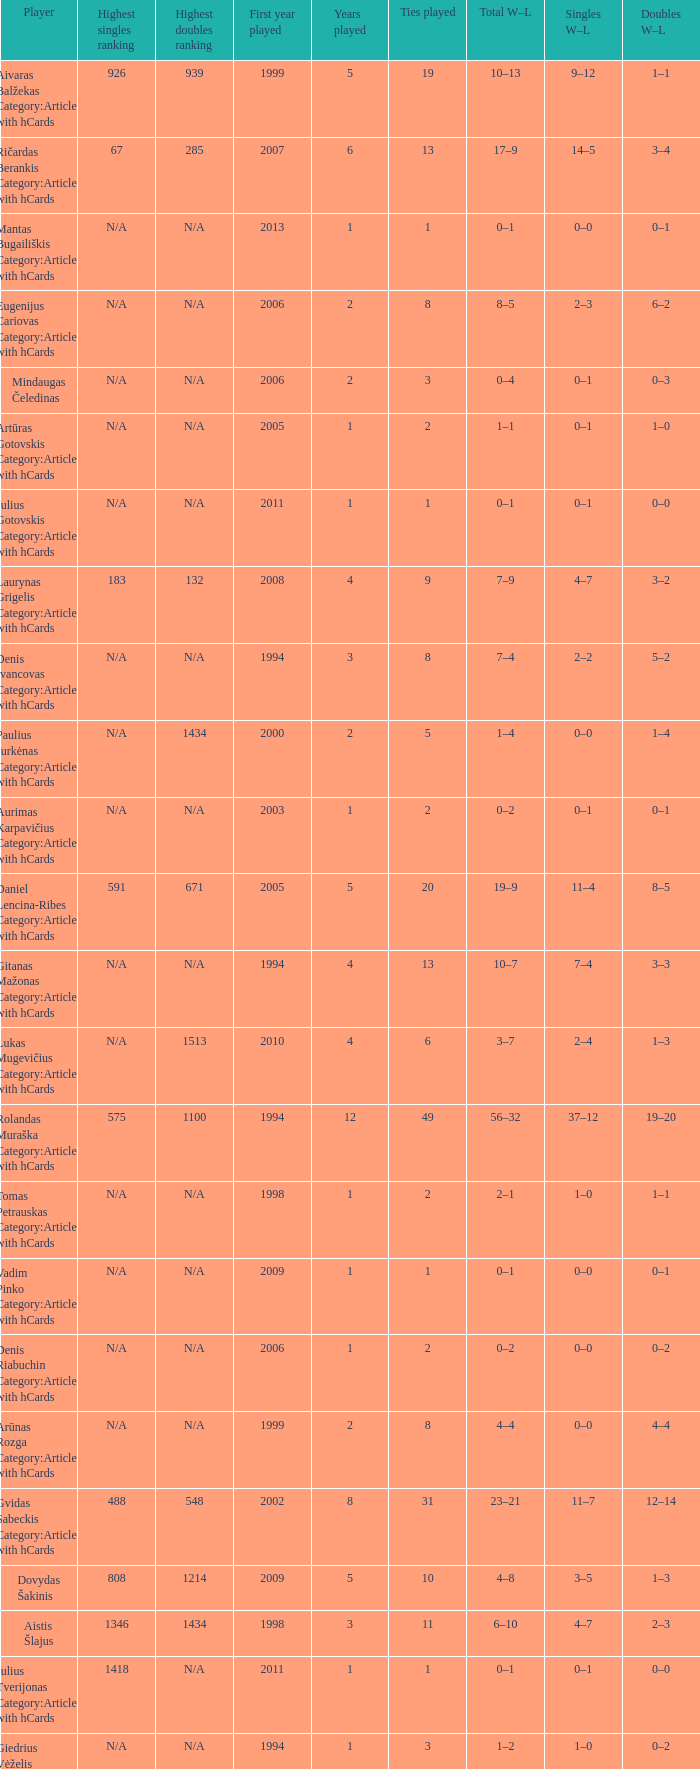Name the minimum tiesplayed for 6 years 13.0. 